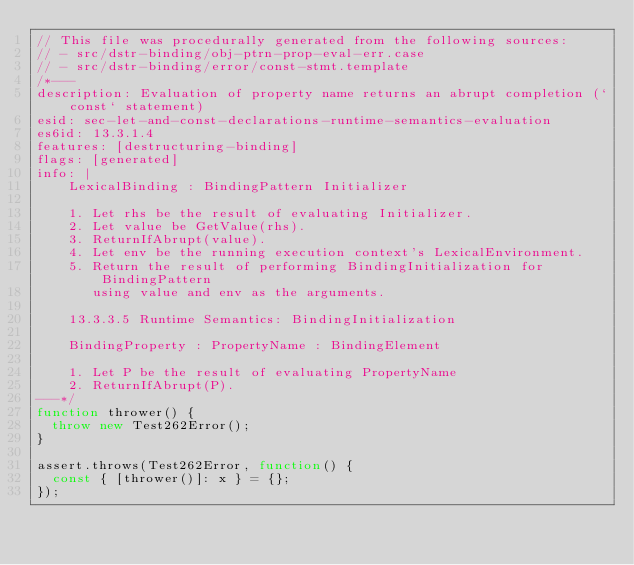Convert code to text. <code><loc_0><loc_0><loc_500><loc_500><_JavaScript_>// This file was procedurally generated from the following sources:
// - src/dstr-binding/obj-ptrn-prop-eval-err.case
// - src/dstr-binding/error/const-stmt.template
/*---
description: Evaluation of property name returns an abrupt completion (`const` statement)
esid: sec-let-and-const-declarations-runtime-semantics-evaluation
es6id: 13.3.1.4
features: [destructuring-binding]
flags: [generated]
info: |
    LexicalBinding : BindingPattern Initializer

    1. Let rhs be the result of evaluating Initializer.
    2. Let value be GetValue(rhs).
    3. ReturnIfAbrupt(value).
    4. Let env be the running execution context's LexicalEnvironment.
    5. Return the result of performing BindingInitialization for BindingPattern
       using value and env as the arguments.

    13.3.3.5 Runtime Semantics: BindingInitialization

    BindingProperty : PropertyName : BindingElement

    1. Let P be the result of evaluating PropertyName
    2. ReturnIfAbrupt(P).
---*/
function thrower() {
  throw new Test262Error();
}

assert.throws(Test262Error, function() {
  const { [thrower()]: x } = {};
});
</code> 